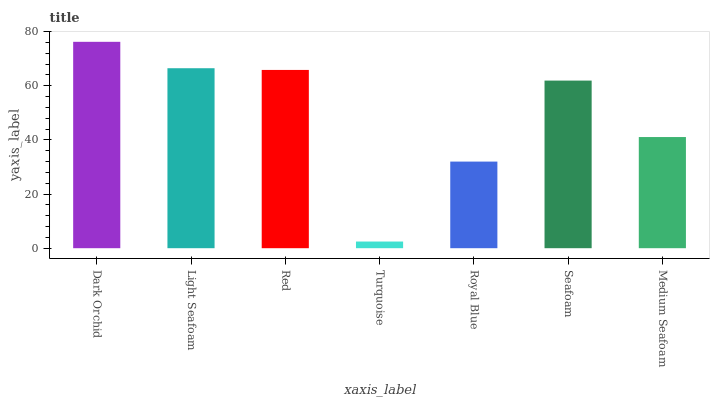Is Turquoise the minimum?
Answer yes or no. Yes. Is Dark Orchid the maximum?
Answer yes or no. Yes. Is Light Seafoam the minimum?
Answer yes or no. No. Is Light Seafoam the maximum?
Answer yes or no. No. Is Dark Orchid greater than Light Seafoam?
Answer yes or no. Yes. Is Light Seafoam less than Dark Orchid?
Answer yes or no. Yes. Is Light Seafoam greater than Dark Orchid?
Answer yes or no. No. Is Dark Orchid less than Light Seafoam?
Answer yes or no. No. Is Seafoam the high median?
Answer yes or no. Yes. Is Seafoam the low median?
Answer yes or no. Yes. Is Light Seafoam the high median?
Answer yes or no. No. Is Light Seafoam the low median?
Answer yes or no. No. 